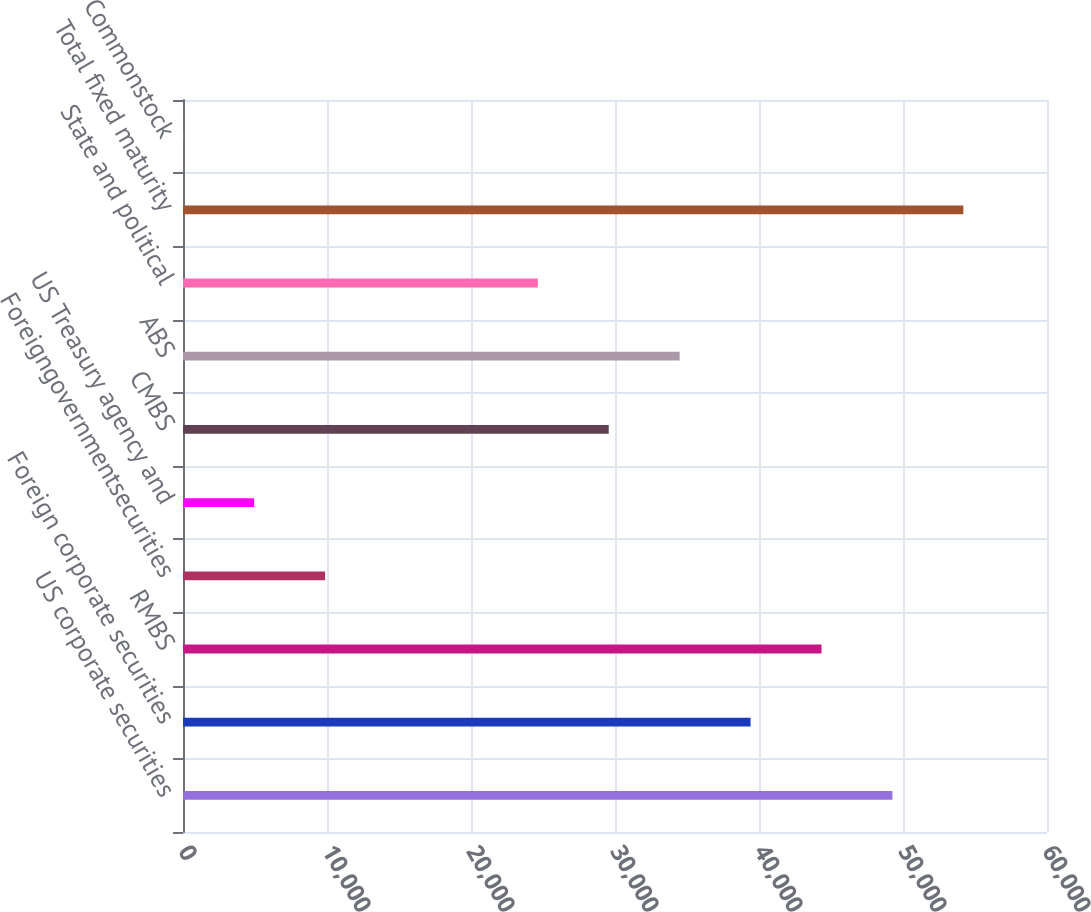Convert chart. <chart><loc_0><loc_0><loc_500><loc_500><bar_chart><fcel>US corporate securities<fcel>Foreign corporate securities<fcel>RMBS<fcel>Foreigngovernmentsecurities<fcel>US Treasury agency and<fcel>CMBS<fcel>ABS<fcel>State and political<fcel>Total fixed maturity<fcel>Commonstock<nl><fcel>49265<fcel>39414.8<fcel>44339.9<fcel>9864.2<fcel>4939.1<fcel>29564.6<fcel>34489.7<fcel>24639.5<fcel>54190.1<fcel>14<nl></chart> 